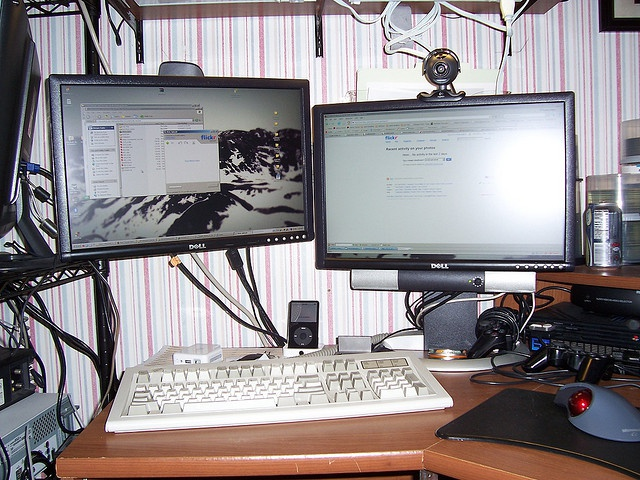Describe the objects in this image and their specific colors. I can see tv in lightblue, darkgray, black, and gray tones, tv in lightblue, lightgray, darkgray, and black tones, keyboard in lightblue, white, darkgray, and lightgray tones, mouse in lightblue, gray, black, and darkblue tones, and mouse in lightblue, black, maroon, gray, and brown tones in this image. 